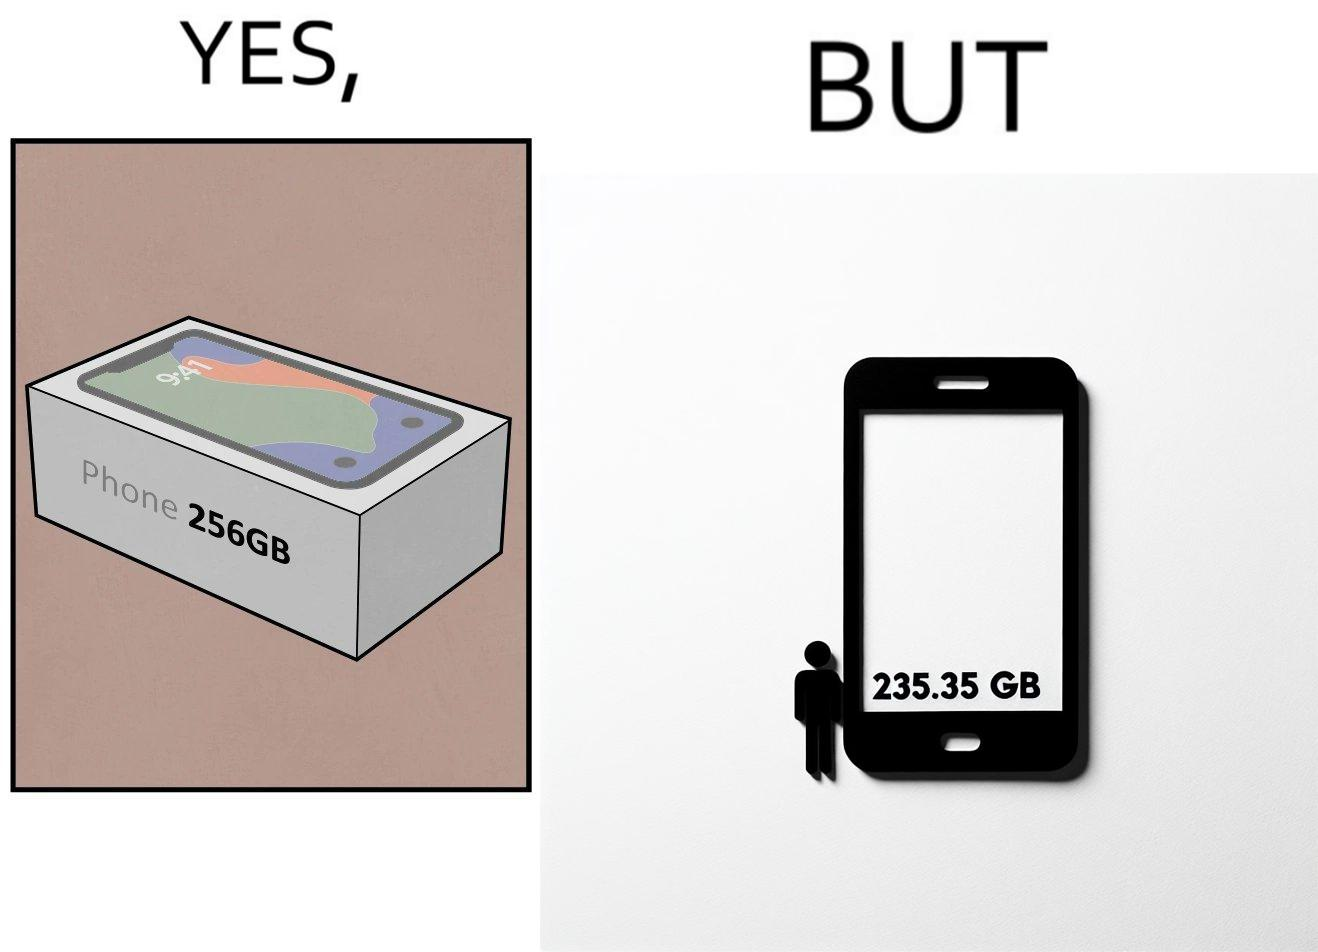Describe the contrast between the left and right parts of this image. In the left part of the image: It is a smartphone box claiming the phone has a storage capacity of 256 gb In the right part of the image: It is a smartphone with 235.35 gb of available space 